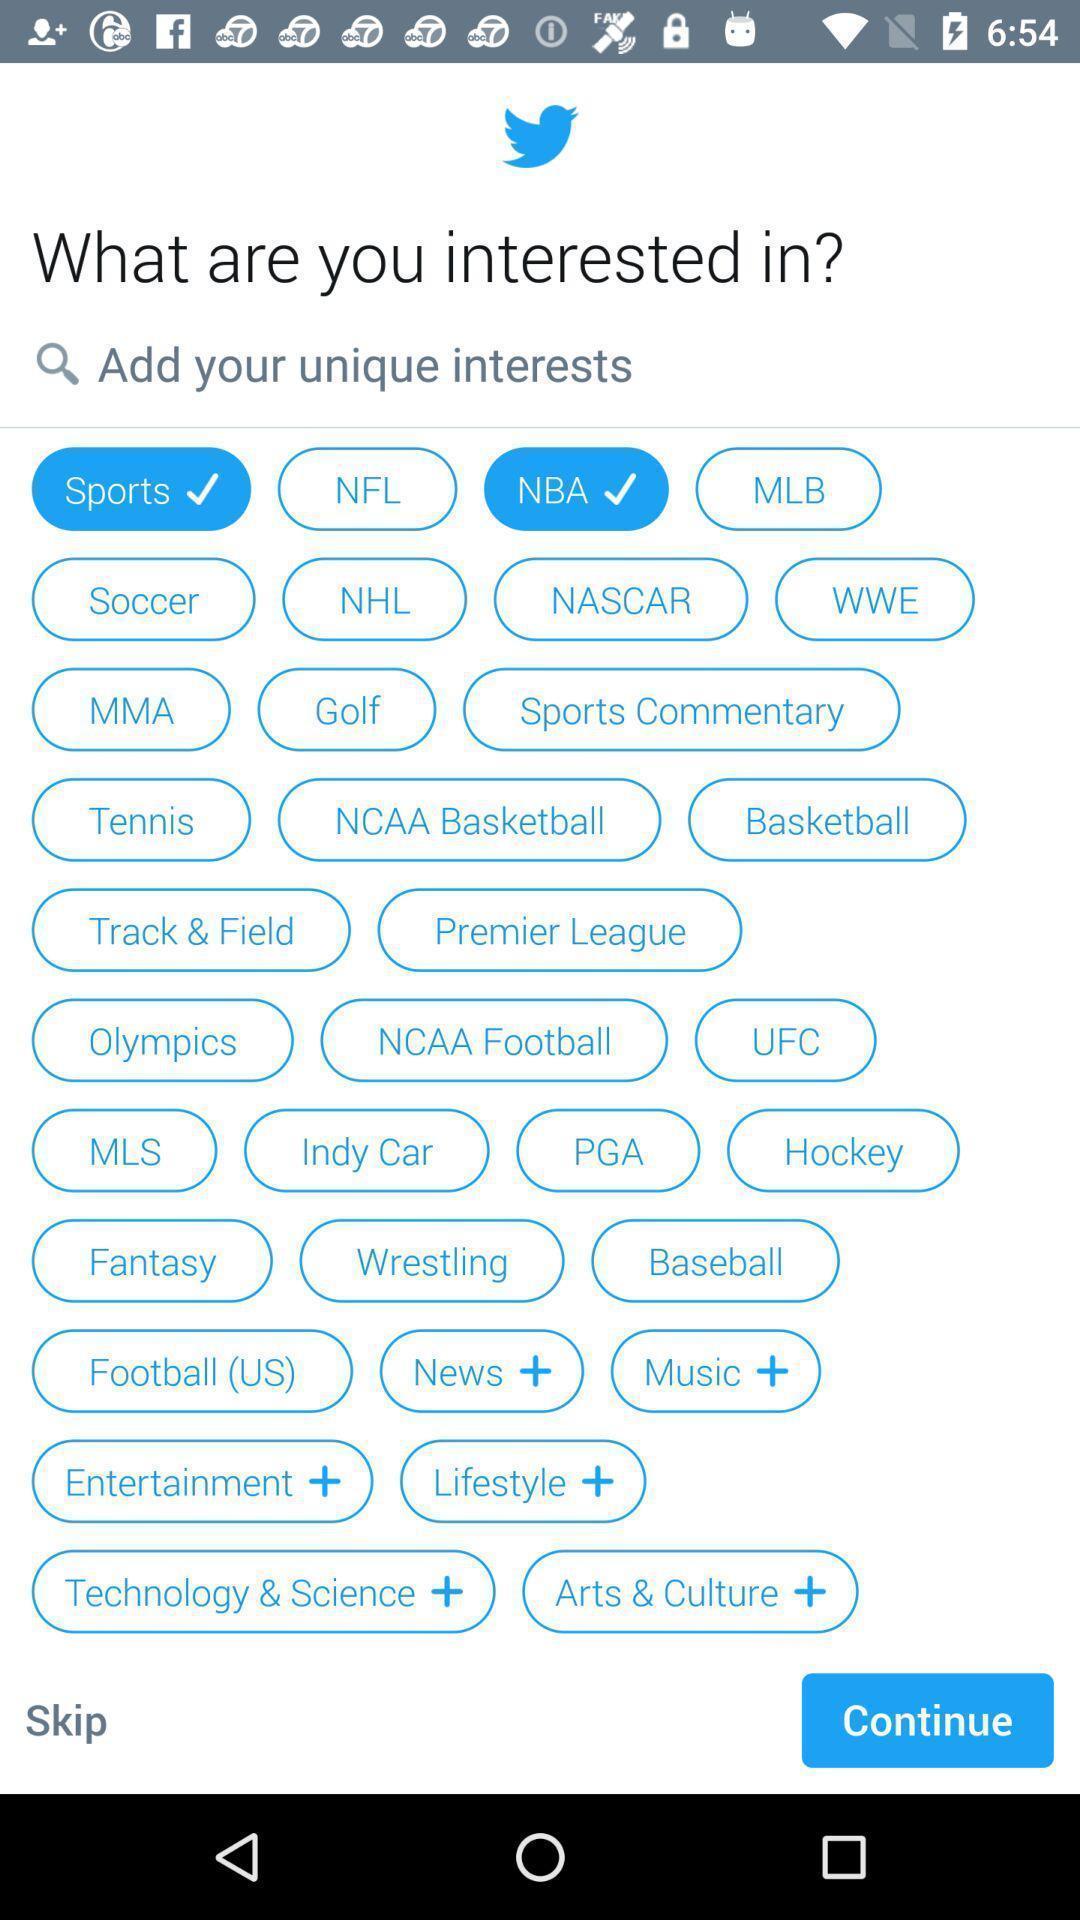Describe the key features of this screenshot. Page showing the suggestions which are interested. 